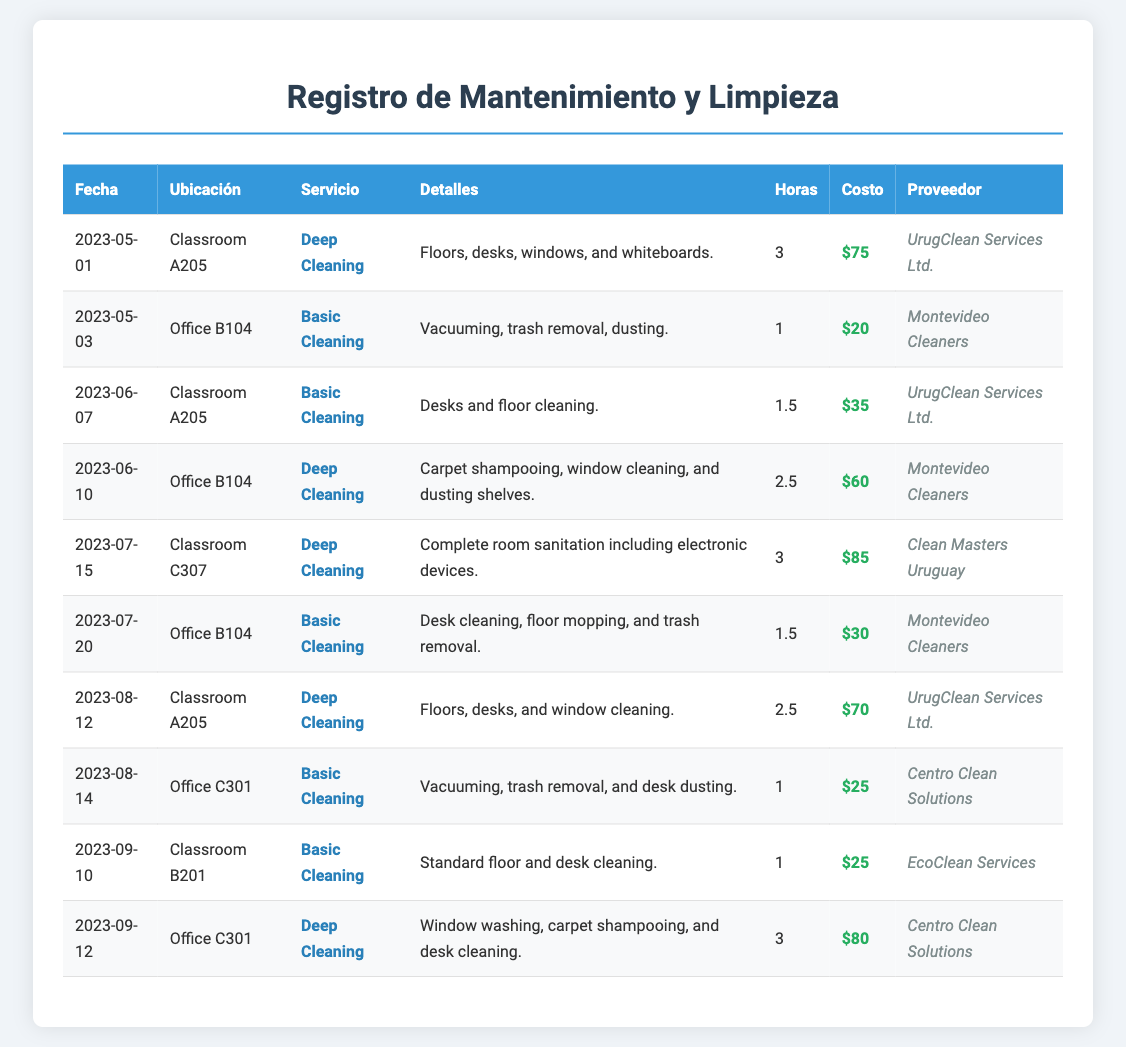What is the date of the first cleaning service? The first cleaning service recorded in the document is on May 1, 2023.
Answer: May 1, 2023 How many hours did the deep cleaning of Classroom A205 take? The deep cleaning of Classroom A205 on May 1, 2023, took 3 hours.
Answer: 3 What was the cost of the basic cleaning service in Office B104 on May 3? The cost for the basic cleaning service in Office B104 on May 3, 2023, is $20.
Answer: $20 Which provider performed the cleaning service in Classroom C307? The cleaning service in Classroom C307 was performed by Clean Masters Uruguay.
Answer: Clean Masters Uruguay What is the total cost for basic cleaning services in the document? The total cost for basic cleaning services can be calculated from the entries which total $20 + $35 + $30 + $25 = $110.
Answer: $110 How many deep cleaning services were conducted in August? There were two deep cleaning services conducted in August 2023.
Answer: 2 Which classroom had the most recent cleaning service? The most recent cleaning service recorded was in Classroom B201 on September 10, 2023.
Answer: Classroom B201 What type of cleaning was performed in Office C301 on September 12? The type of cleaning performed in Office C301 on September 12, 2023, was deep cleaning.
Answer: Deep Cleaning What was the cost of cleaning service provided by Montevideo Cleaners? The total cost of services provided by Montevideo Cleaners can be calculated as $20 + $60 + $30 = $110.
Answer: $110 